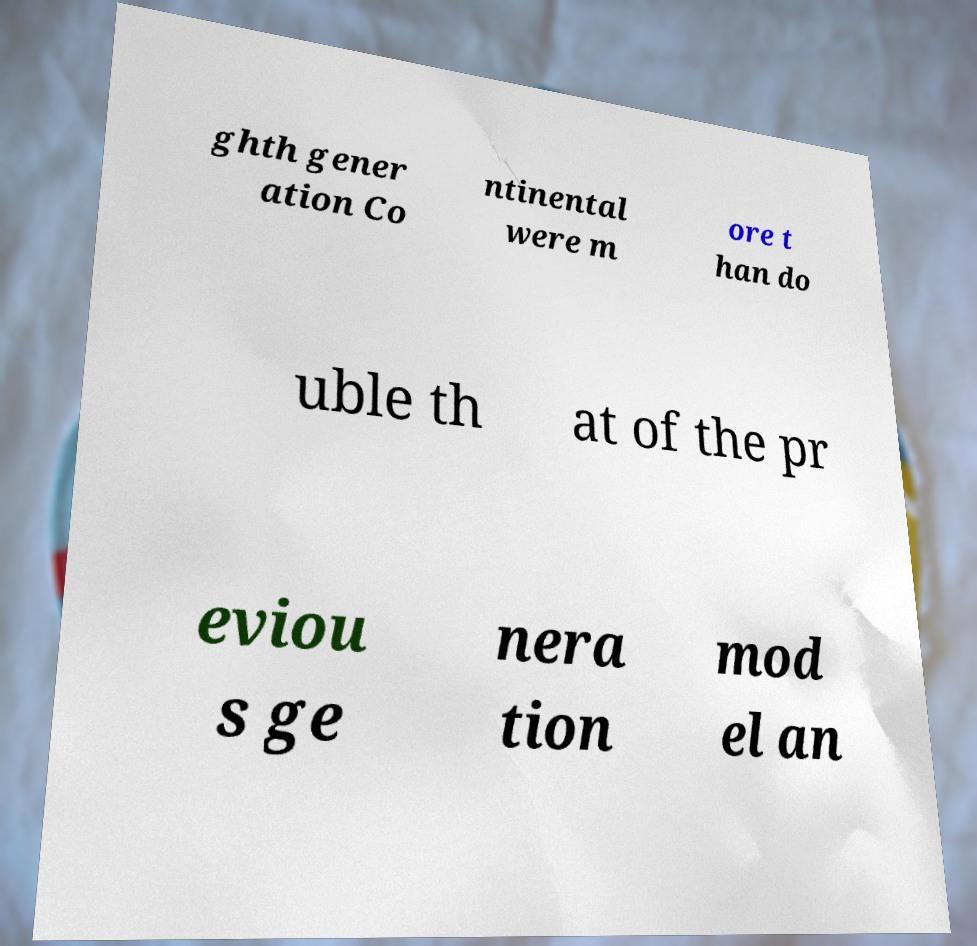Could you extract and type out the text from this image? ghth gener ation Co ntinental were m ore t han do uble th at of the pr eviou s ge nera tion mod el an 